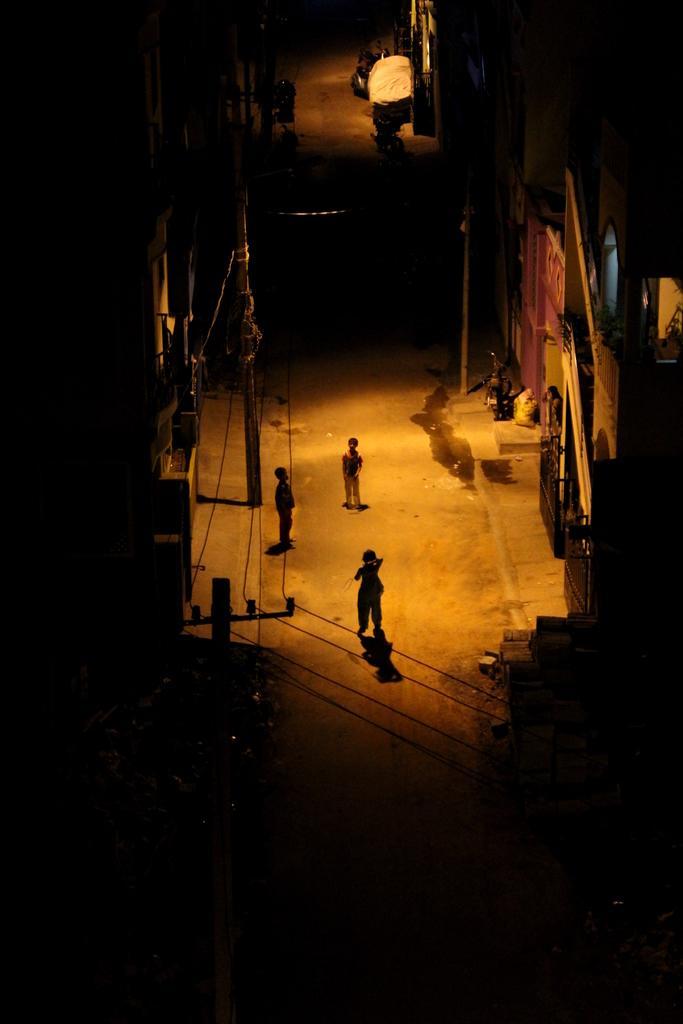Could you give a brief overview of what you see in this image? In this image we can see three kids on a road. Beside the kids we can see buildings and electric poles with wires. At the top we can see few buildings and vehicles. The background of the image is dark. 